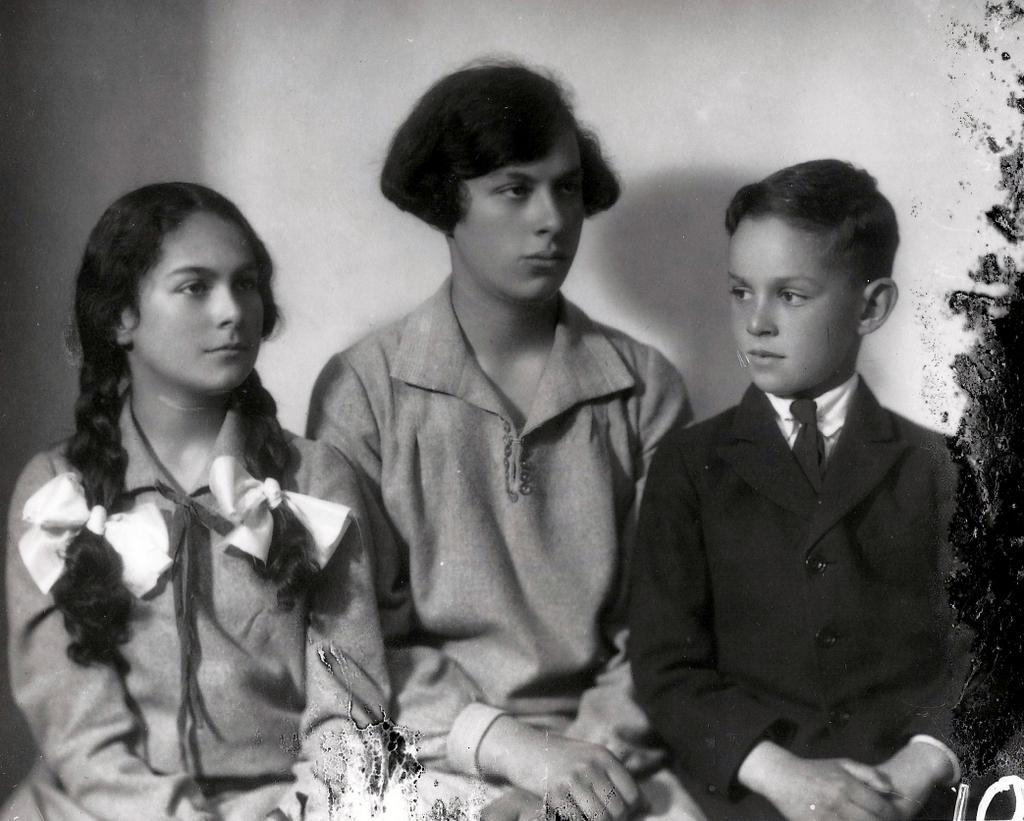What is the color scheme of the image? The image is black and white. Who are the subjects in the image? There is a girl and two boys in the image. What are the subjects doing in the image? The girl and boys are sitting. What can be seen in the background of the image? There is a wall in the background of the image. What type of feather can be seen on the girl's hat in the image? There is no feather present on the girl's hat in the image, as the image is black and white and does not show any details of clothing or accessories. 